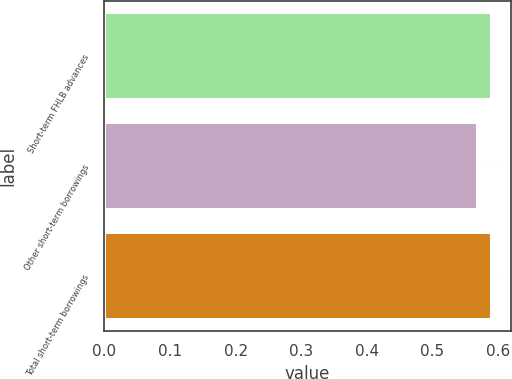Convert chart to OTSL. <chart><loc_0><loc_0><loc_500><loc_500><bar_chart><fcel>Short-term FHLB advances<fcel>Other short-term borrowings<fcel>Total short-term borrowings<nl><fcel>0.59<fcel>0.57<fcel>0.59<nl></chart> 